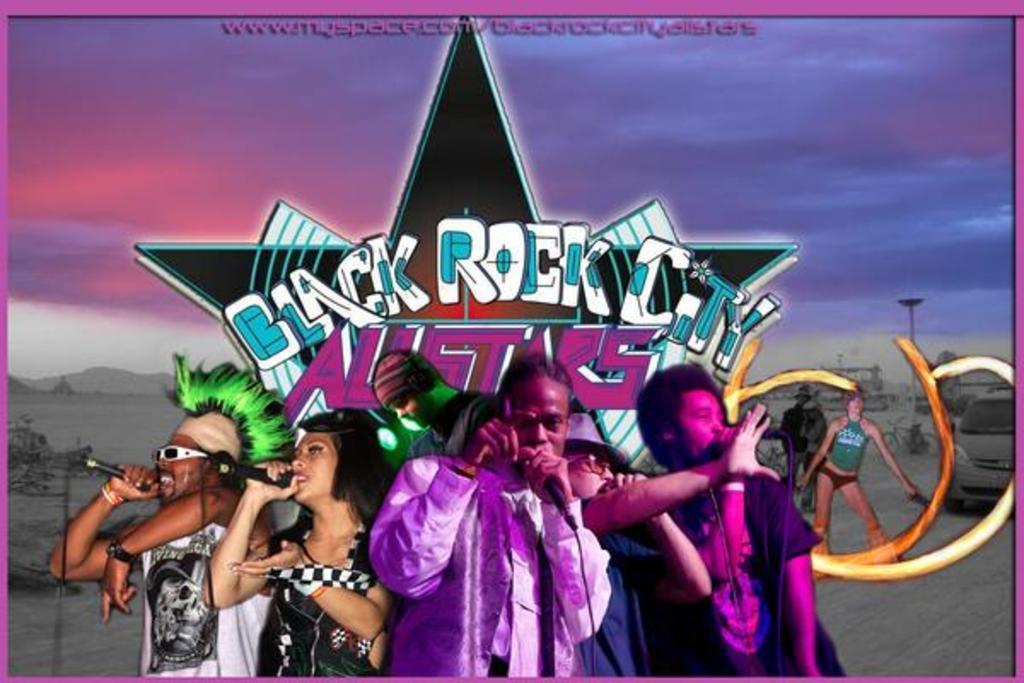How would you summarize this image in a sentence or two? In this picture there are group of people standing and holding the microphones. At the back there is a picture of a star and there is a text and there are mountains and trees and there is a pole, car, bicycle. At the top there is sky and there are clouds. 